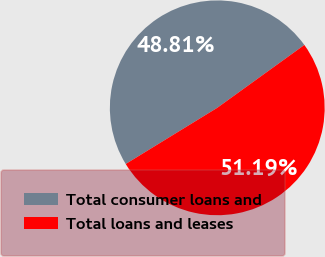<chart> <loc_0><loc_0><loc_500><loc_500><pie_chart><fcel>Total consumer loans and<fcel>Total loans and leases<nl><fcel>48.81%<fcel>51.19%<nl></chart> 